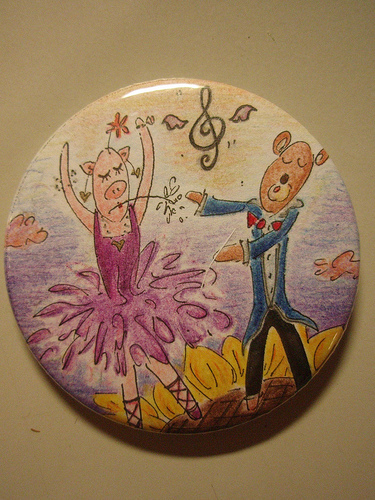<image>
Is the ballerina on the flower? Yes. Looking at the image, I can see the ballerina is positioned on top of the flower, with the flower providing support. 